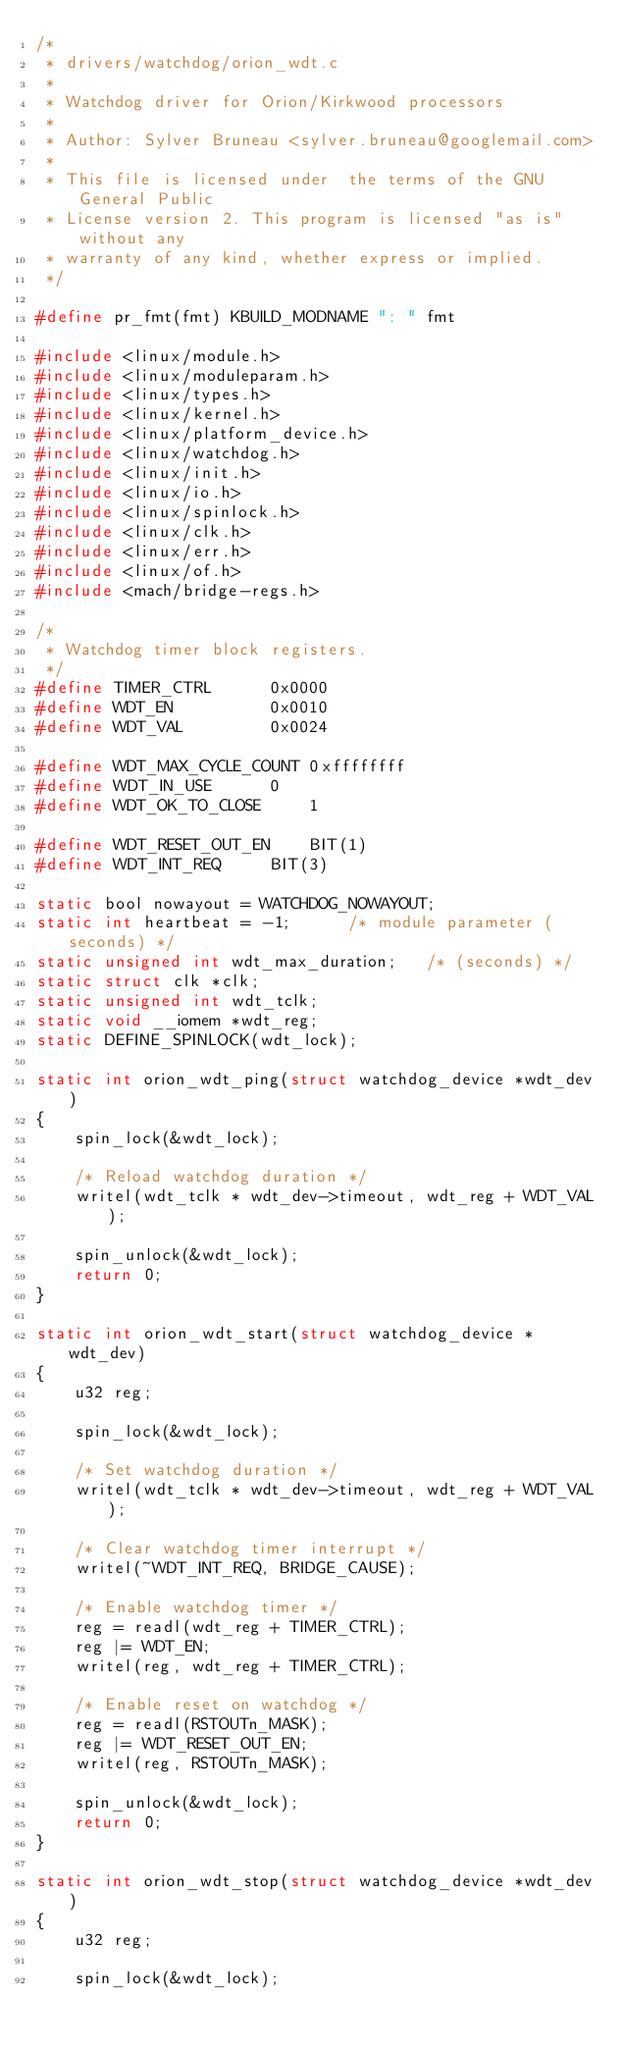<code> <loc_0><loc_0><loc_500><loc_500><_C_>/*
 * drivers/watchdog/orion_wdt.c
 *
 * Watchdog driver for Orion/Kirkwood processors
 *
 * Author: Sylver Bruneau <sylver.bruneau@googlemail.com>
 *
 * This file is licensed under  the terms of the GNU General Public
 * License version 2. This program is licensed "as is" without any
 * warranty of any kind, whether express or implied.
 */

#define pr_fmt(fmt) KBUILD_MODNAME ": " fmt

#include <linux/module.h>
#include <linux/moduleparam.h>
#include <linux/types.h>
#include <linux/kernel.h>
#include <linux/platform_device.h>
#include <linux/watchdog.h>
#include <linux/init.h>
#include <linux/io.h>
#include <linux/spinlock.h>
#include <linux/clk.h>
#include <linux/err.h>
#include <linux/of.h>
#include <mach/bridge-regs.h>

/*
 * Watchdog timer block registers.
 */
#define TIMER_CTRL		0x0000
#define WDT_EN			0x0010
#define WDT_VAL			0x0024

#define WDT_MAX_CYCLE_COUNT	0xffffffff
#define WDT_IN_USE		0
#define WDT_OK_TO_CLOSE		1

#define WDT_RESET_OUT_EN	BIT(1)
#define WDT_INT_REQ		BIT(3)

static bool nowayout = WATCHDOG_NOWAYOUT;
static int heartbeat = -1;		/* module parameter (seconds) */
static unsigned int wdt_max_duration;	/* (seconds) */
static struct clk *clk;
static unsigned int wdt_tclk;
static void __iomem *wdt_reg;
static DEFINE_SPINLOCK(wdt_lock);

static int orion_wdt_ping(struct watchdog_device *wdt_dev)
{
	spin_lock(&wdt_lock);

	/* Reload watchdog duration */
	writel(wdt_tclk * wdt_dev->timeout, wdt_reg + WDT_VAL);

	spin_unlock(&wdt_lock);
	return 0;
}

static int orion_wdt_start(struct watchdog_device *wdt_dev)
{
	u32 reg;

	spin_lock(&wdt_lock);

	/* Set watchdog duration */
	writel(wdt_tclk * wdt_dev->timeout, wdt_reg + WDT_VAL);

	/* Clear watchdog timer interrupt */
	writel(~WDT_INT_REQ, BRIDGE_CAUSE);

	/* Enable watchdog timer */
	reg = readl(wdt_reg + TIMER_CTRL);
	reg |= WDT_EN;
	writel(reg, wdt_reg + TIMER_CTRL);

	/* Enable reset on watchdog */
	reg = readl(RSTOUTn_MASK);
	reg |= WDT_RESET_OUT_EN;
	writel(reg, RSTOUTn_MASK);

	spin_unlock(&wdt_lock);
	return 0;
}

static int orion_wdt_stop(struct watchdog_device *wdt_dev)
{
	u32 reg;

	spin_lock(&wdt_lock);
</code> 